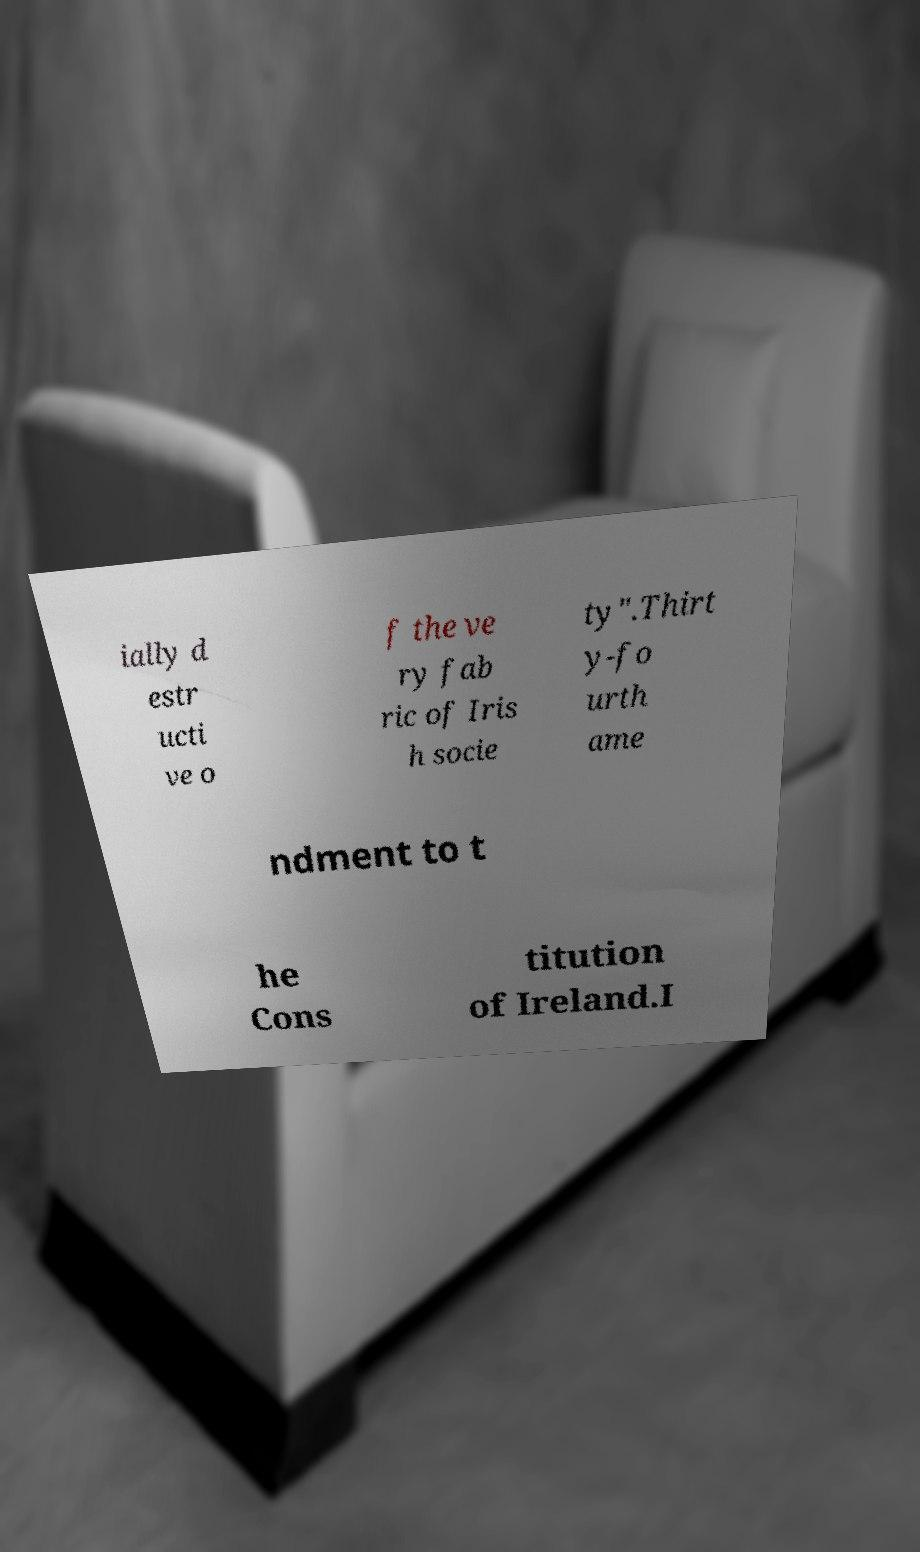Could you extract and type out the text from this image? ially d estr ucti ve o f the ve ry fab ric of Iris h socie ty".Thirt y-fo urth ame ndment to t he Cons titution of Ireland.I 